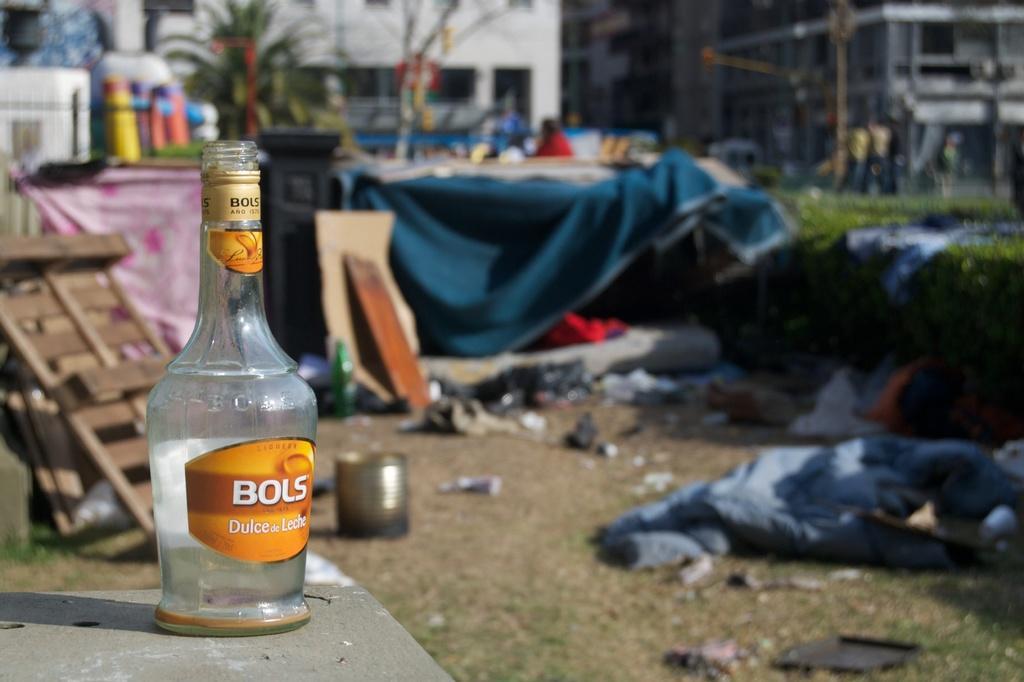Can you describe this image briefly? There is a glass bottle, at the back there is a white color building, there is a tree, there is a blue color sheet and at the right there is a plant and there are people at the back and there is garbage on the ground. 